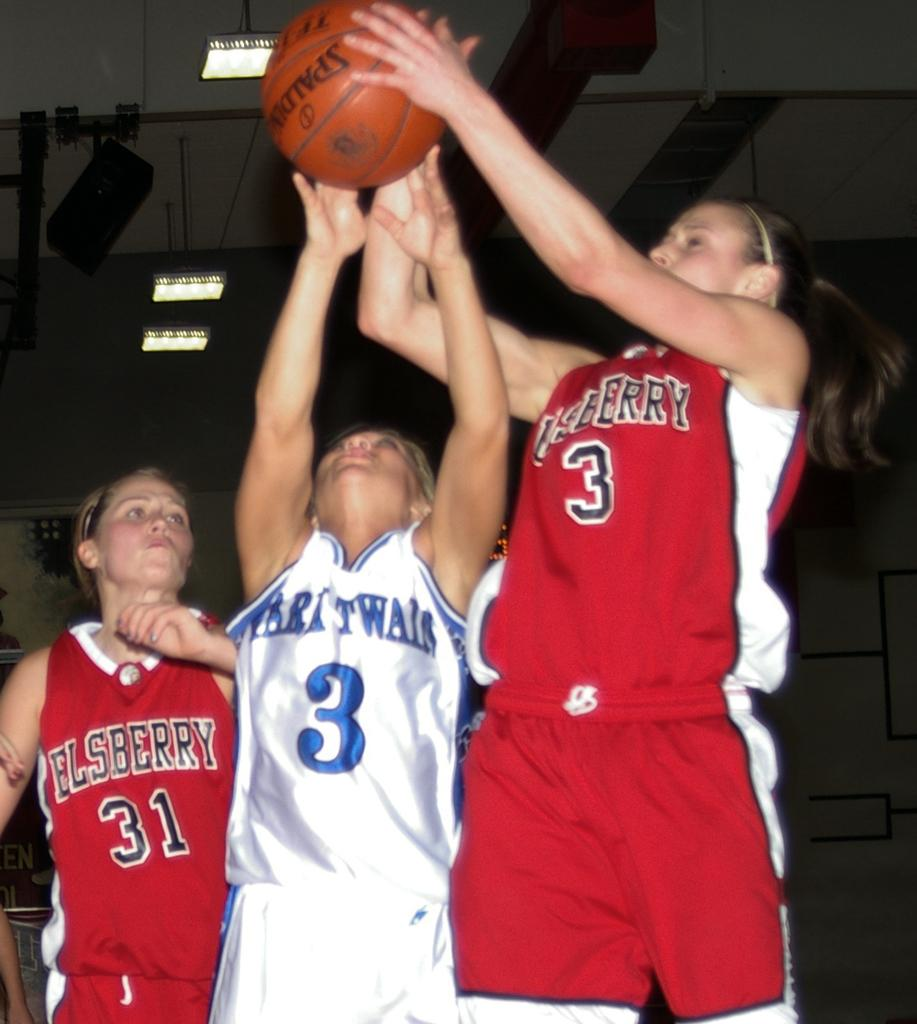<image>
Share a concise interpretation of the image provided. Player number 3 in red is going for a shot as player number 3 in white is trying to stop her. 